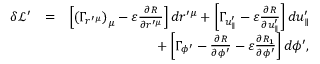<formula> <loc_0><loc_0><loc_500><loc_500>\begin{array} { r l r } { \delta \mathcal { L } ^ { \prime } } & { = } & { \left [ \left ( \Gamma _ { r ^ { \prime \mu } } \right ) _ { \mu } - \varepsilon \frac { \partial R } { \partial r ^ { \prime \mu } } \right ] d r ^ { \prime \mu } + \left [ \Gamma _ { u _ { \| } ^ { \prime } } - \varepsilon \frac { \partial R } { \partial u _ { \| } ^ { \prime } } \right ] d u _ { \| } ^ { \prime } } \\ & { + \left [ \Gamma _ { \phi ^ { \prime } } - \frac { \partial R } { \partial \phi ^ { \prime } } - \varepsilon \frac { \partial R _ { 1 } } { \partial \phi ^ { \prime } } \right ] d \phi ^ { \prime } , } \end{array}</formula> 